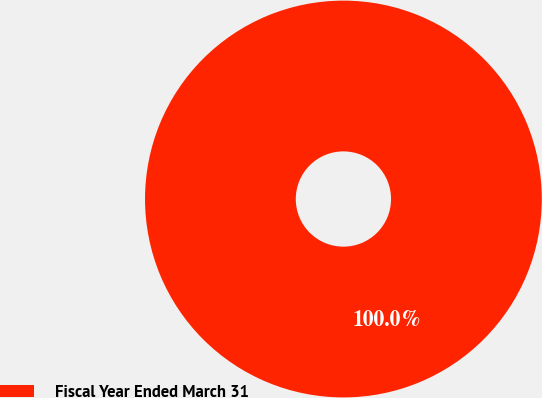<chart> <loc_0><loc_0><loc_500><loc_500><pie_chart><fcel>Fiscal Year Ended March 31<nl><fcel>100.0%<nl></chart> 